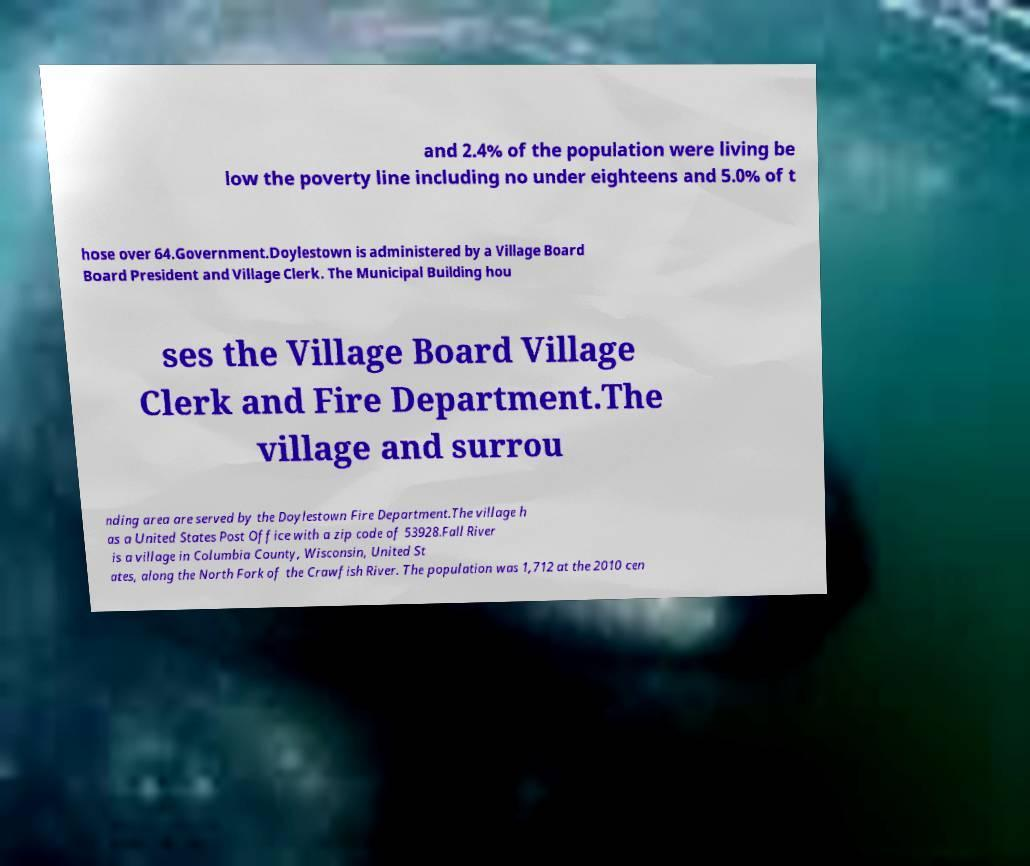Please identify and transcribe the text found in this image. and 2.4% of the population were living be low the poverty line including no under eighteens and 5.0% of t hose over 64.Government.Doylestown is administered by a Village Board Board President and Village Clerk. The Municipal Building hou ses the Village Board Village Clerk and Fire Department.The village and surrou nding area are served by the Doylestown Fire Department.The village h as a United States Post Office with a zip code of 53928.Fall River is a village in Columbia County, Wisconsin, United St ates, along the North Fork of the Crawfish River. The population was 1,712 at the 2010 cen 